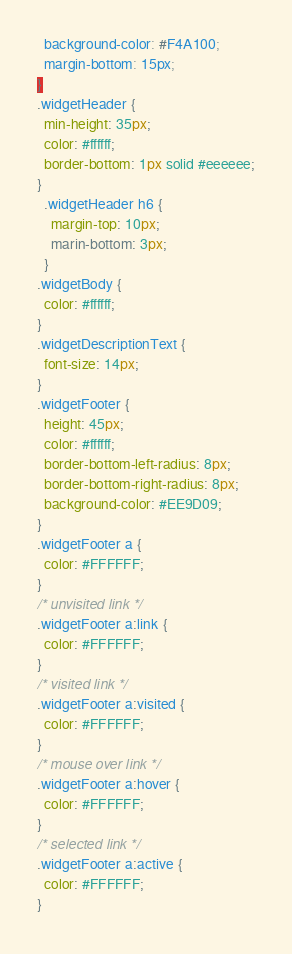<code> <loc_0><loc_0><loc_500><loc_500><_CSS_>  background-color: #F4A100;
  margin-bottom: 15px;
}
.widgetHeader {
  min-height: 35px;
  color: #ffffff;
  border-bottom: 1px solid #eeeeee;
}
  .widgetHeader h6 {
    margin-top: 10px;
    marin-bottom: 3px;
  }
.widgetBody {
  color: #ffffff;
}
.widgetDescriptionText {
  font-size: 14px;
}
.widgetFooter {
  height: 45px;
  color: #ffffff;
  border-bottom-left-radius: 8px;
  border-bottom-right-radius: 8px;
  background-color: #EE9D09;
}
.widgetFooter a {
  color: #FFFFFF;
}
/* unvisited link */
.widgetFooter a:link {
  color: #FFFFFF;
}
/* visited link */
.widgetFooter a:visited {
  color: #FFFFFF;
}
/* mouse over link */
.widgetFooter a:hover {
  color: #FFFFFF;
}
/* selected link */
.widgetFooter a:active {
  color: #FFFFFF;
}
</code> 